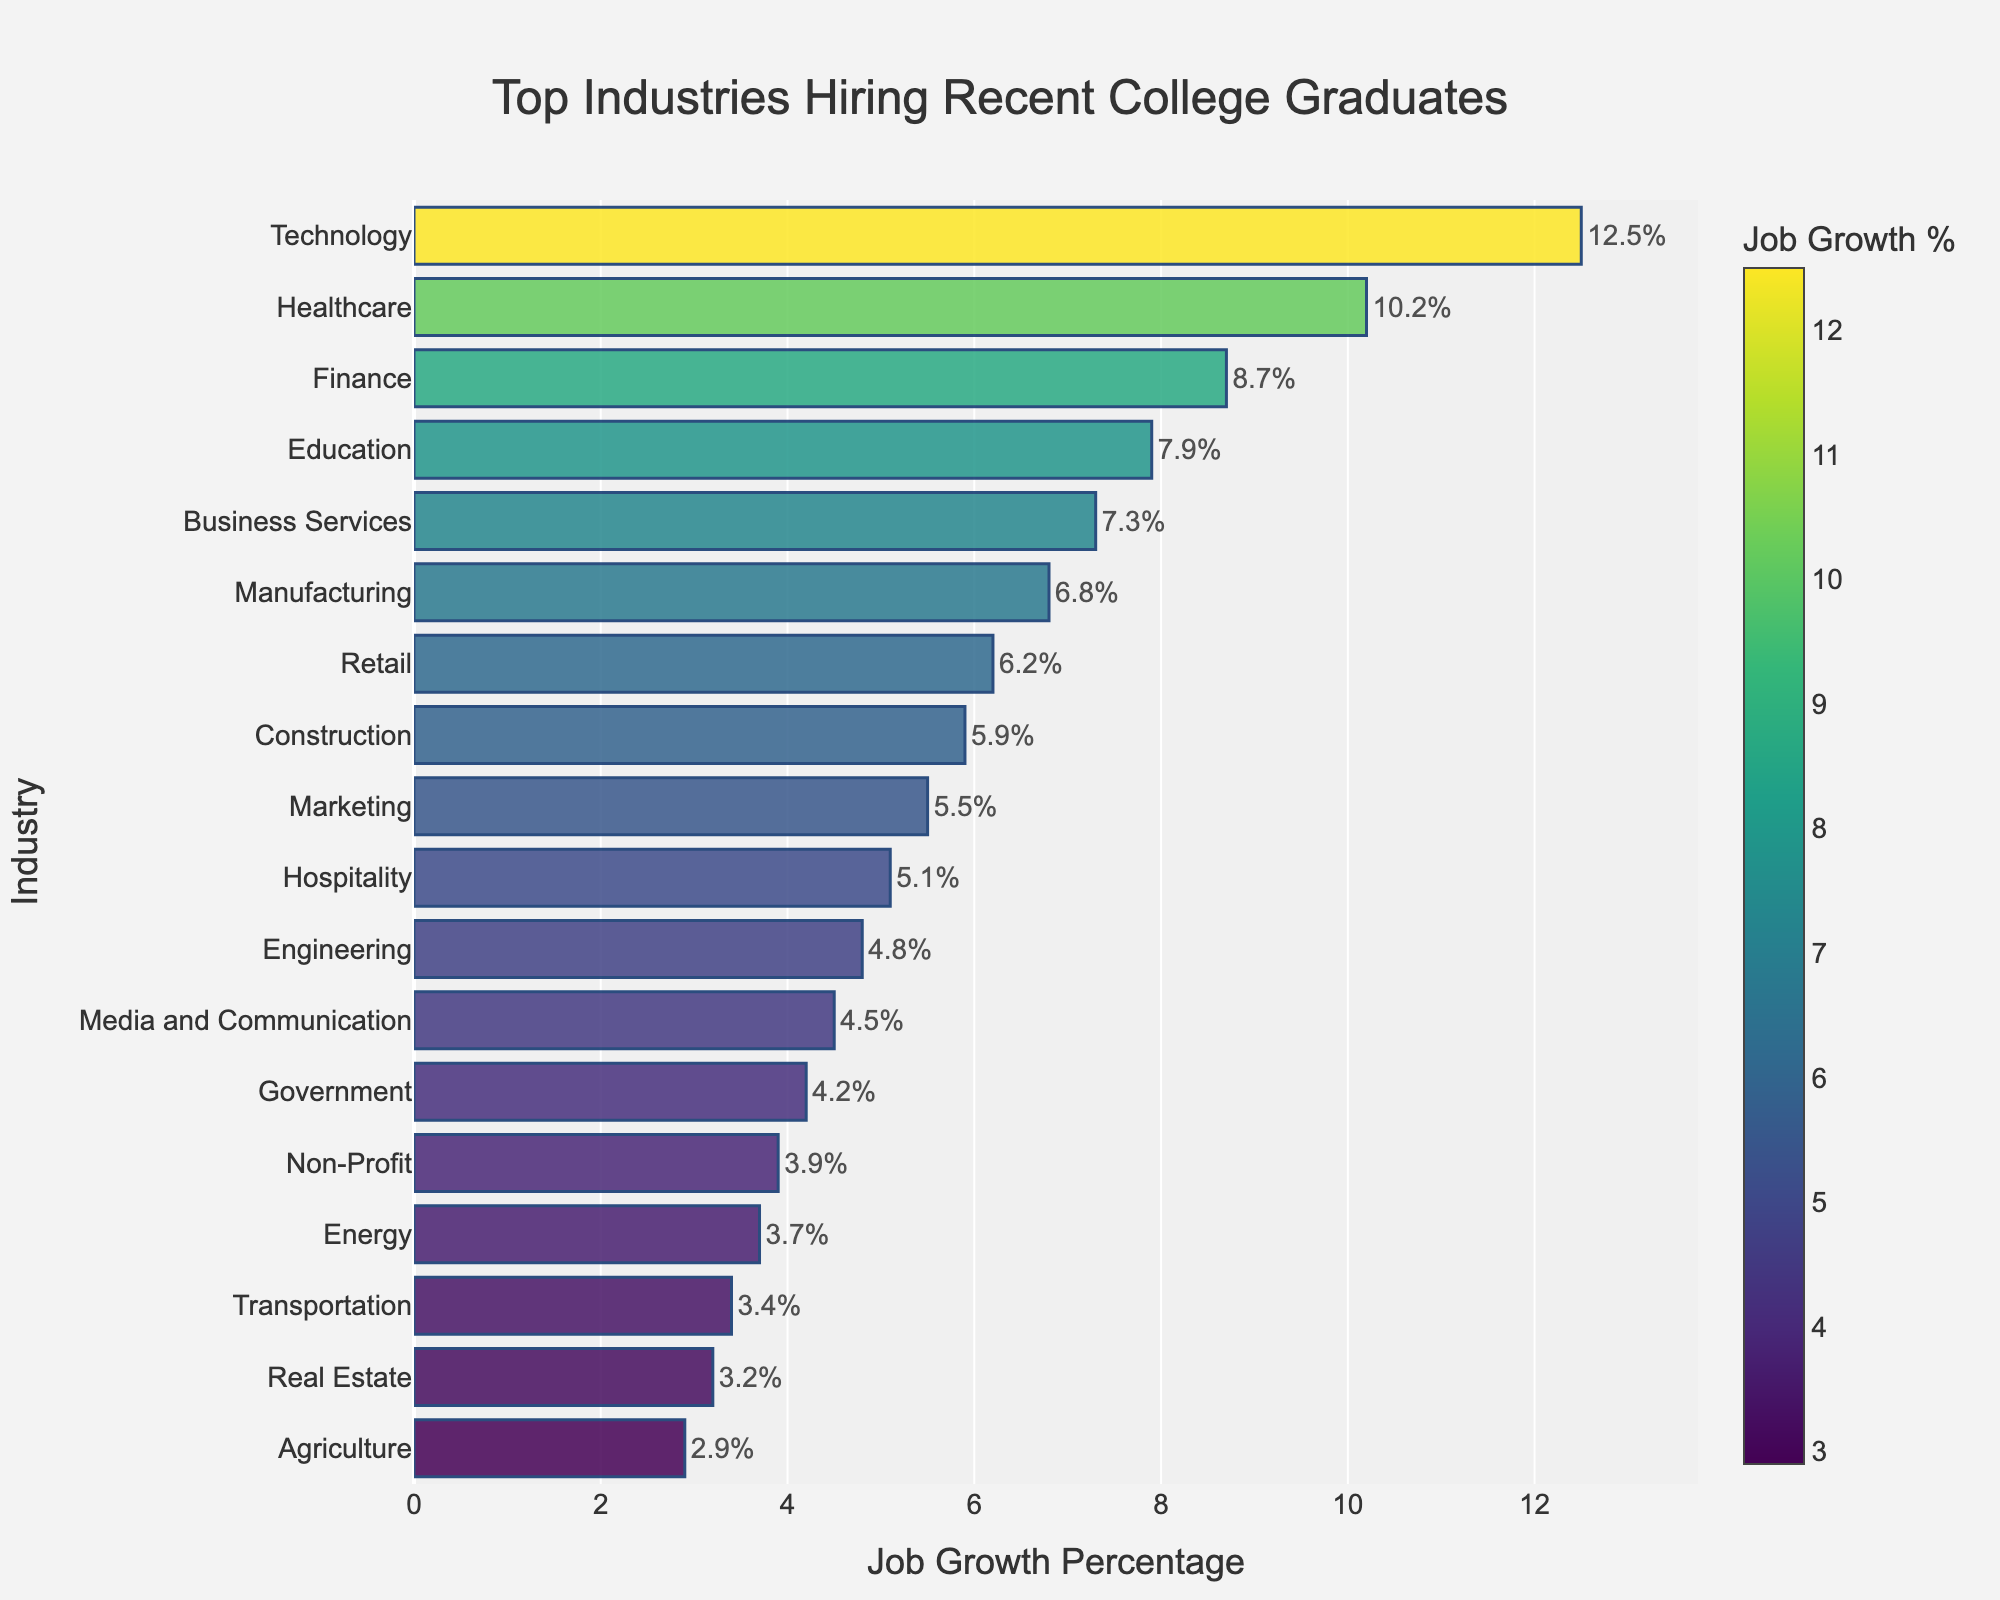Which industry has the highest job growth percentage? The highest bar corresponds to the Technology industry with a job growth percentage of 12.5%.
Answer: Technology What is the job growth percentage difference between Healthcare and Finance? The job growth percentage for Healthcare is 10.2%, while for Finance it is 8.7%. Subtracting these, 10.2% - 8.7% = 1.5%.
Answer: 1.5% Which industries have a job growth percentage less than 5%? The bars corresponding to industries with less than 5% job growth are Engineering, Media and Communication, Government, Non-Profit, Energy, Transportation, Real Estate, and Agriculture.
Answer: Engineering, Media and Communication, Government, Non-Profit, Energy, Transportation, Real Estate, Agriculture How many industries have a job growth rate greater than or equal to 6%? Counting the bars with job growth percentage of 6% or more, the industries are Technology, Healthcare, Finance, Education, Business Services, Manufacturing, and Retail. This makes a total of 7 industries.
Answer: 7 Which industry shows a job growth percentage closest to the average job growth percentage across all industries? Calculate the average job growth percentage by summing all values and dividing by the number of industries (12.5 + 10.2 + 8.7 + 7.9 + 7.3 + 6.8 + 6.2 + 5.9 + 5.5 + 5.1 + 4.8 + 4.5 + 4.2 + 3.9 + 3.7 + 3.4 + 3.2 + 2.9 = 107.7 / 18 ≈ 5.98). The industry closest to this average is Retail, with 6.2%.
Answer: Retail Which industry has the lowest job growth percentage? The shortest bar, indicating the lowest value, corresponds to Agriculture with a job growth percentage of 2.9%.
Answer: Agriculture What is the combined job growth percentage of the top three industries? The top three industries are Technology (12.5%), Healthcare (10.2%), and Finance (8.7%). Summing these gives 12.5% + 10.2% + 8.7% = 31.4%.
Answer: 31.4% Is the job growth percentage in Education higher or lower than in Business Services? The job growth percentage for Education is 7.9%, while for Business Services it is 7.3%. Therefore, Education has a higher job growth percentage than Business Services.
Answer: Higher What is the median job growth percentage across all industries? Sorting the job growth percentages in ascending order and finding the middle value, we get the median of (5.5 + 5.1) / 2 = 5.3% as the middle two values fall at 5.5% and 5.1%.
Answer: 5.3% Which two industries have nearly equal job growth percentages and what are their values? The industries with nearly equal job growth percentages are Marketing (5.5%) and Hospitality (5.1%) with a difference of only 0.4%.
Answer: Marketing and Hospitality 